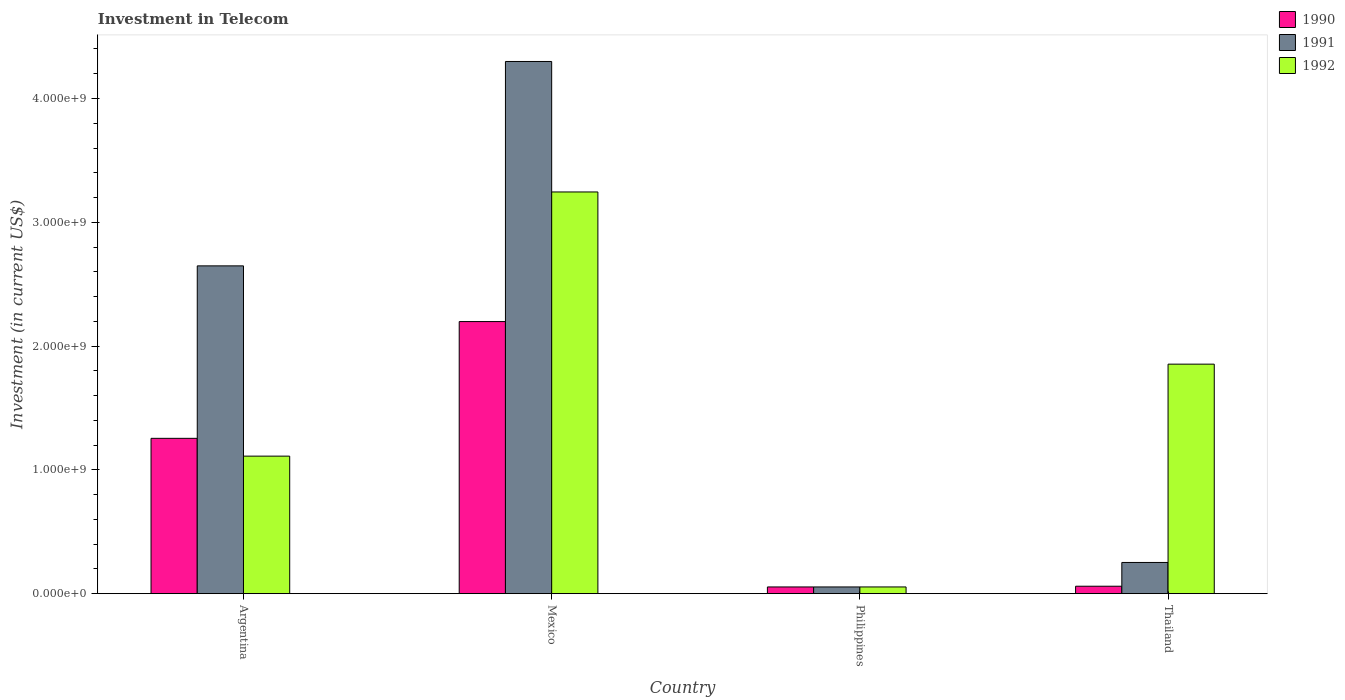How many different coloured bars are there?
Ensure brevity in your answer.  3. Are the number of bars on each tick of the X-axis equal?
Your response must be concise. Yes. How many bars are there on the 4th tick from the left?
Your response must be concise. 3. What is the amount invested in telecom in 1990 in Thailand?
Ensure brevity in your answer.  6.00e+07. Across all countries, what is the maximum amount invested in telecom in 1990?
Offer a terse response. 2.20e+09. Across all countries, what is the minimum amount invested in telecom in 1992?
Ensure brevity in your answer.  5.42e+07. In which country was the amount invested in telecom in 1990 maximum?
Provide a succinct answer. Mexico. In which country was the amount invested in telecom in 1991 minimum?
Make the answer very short. Philippines. What is the total amount invested in telecom in 1992 in the graph?
Your answer should be very brief. 6.26e+09. What is the difference between the amount invested in telecom in 1991 in Mexico and that in Thailand?
Provide a succinct answer. 4.05e+09. What is the difference between the amount invested in telecom in 1990 in Argentina and the amount invested in telecom in 1992 in Thailand?
Ensure brevity in your answer.  -5.99e+08. What is the average amount invested in telecom in 1991 per country?
Make the answer very short. 1.81e+09. What is the difference between the amount invested in telecom of/in 1991 and amount invested in telecom of/in 1990 in Argentina?
Your answer should be very brief. 1.39e+09. What is the ratio of the amount invested in telecom in 1992 in Argentina to that in Mexico?
Offer a terse response. 0.34. What is the difference between the highest and the second highest amount invested in telecom in 1992?
Make the answer very short. 1.39e+09. What is the difference between the highest and the lowest amount invested in telecom in 1991?
Provide a succinct answer. 4.24e+09. In how many countries, is the amount invested in telecom in 1990 greater than the average amount invested in telecom in 1990 taken over all countries?
Provide a short and direct response. 2. What does the 3rd bar from the left in Argentina represents?
Your answer should be very brief. 1992. Is it the case that in every country, the sum of the amount invested in telecom in 1992 and amount invested in telecom in 1991 is greater than the amount invested in telecom in 1990?
Keep it short and to the point. Yes. Are all the bars in the graph horizontal?
Your answer should be compact. No. Are the values on the major ticks of Y-axis written in scientific E-notation?
Offer a very short reply. Yes. Where does the legend appear in the graph?
Your response must be concise. Top right. How many legend labels are there?
Keep it short and to the point. 3. What is the title of the graph?
Provide a succinct answer. Investment in Telecom. Does "1965" appear as one of the legend labels in the graph?
Ensure brevity in your answer.  No. What is the label or title of the Y-axis?
Provide a short and direct response. Investment (in current US$). What is the Investment (in current US$) in 1990 in Argentina?
Make the answer very short. 1.25e+09. What is the Investment (in current US$) in 1991 in Argentina?
Your response must be concise. 2.65e+09. What is the Investment (in current US$) in 1992 in Argentina?
Give a very brief answer. 1.11e+09. What is the Investment (in current US$) of 1990 in Mexico?
Give a very brief answer. 2.20e+09. What is the Investment (in current US$) of 1991 in Mexico?
Your response must be concise. 4.30e+09. What is the Investment (in current US$) in 1992 in Mexico?
Offer a terse response. 3.24e+09. What is the Investment (in current US$) of 1990 in Philippines?
Keep it short and to the point. 5.42e+07. What is the Investment (in current US$) of 1991 in Philippines?
Offer a terse response. 5.42e+07. What is the Investment (in current US$) in 1992 in Philippines?
Your response must be concise. 5.42e+07. What is the Investment (in current US$) in 1990 in Thailand?
Keep it short and to the point. 6.00e+07. What is the Investment (in current US$) of 1991 in Thailand?
Offer a terse response. 2.52e+08. What is the Investment (in current US$) of 1992 in Thailand?
Keep it short and to the point. 1.85e+09. Across all countries, what is the maximum Investment (in current US$) in 1990?
Provide a succinct answer. 2.20e+09. Across all countries, what is the maximum Investment (in current US$) of 1991?
Offer a very short reply. 4.30e+09. Across all countries, what is the maximum Investment (in current US$) in 1992?
Provide a succinct answer. 3.24e+09. Across all countries, what is the minimum Investment (in current US$) in 1990?
Give a very brief answer. 5.42e+07. Across all countries, what is the minimum Investment (in current US$) in 1991?
Keep it short and to the point. 5.42e+07. Across all countries, what is the minimum Investment (in current US$) in 1992?
Your answer should be compact. 5.42e+07. What is the total Investment (in current US$) of 1990 in the graph?
Provide a short and direct response. 3.57e+09. What is the total Investment (in current US$) in 1991 in the graph?
Offer a terse response. 7.25e+09. What is the total Investment (in current US$) of 1992 in the graph?
Provide a short and direct response. 6.26e+09. What is the difference between the Investment (in current US$) of 1990 in Argentina and that in Mexico?
Your response must be concise. -9.43e+08. What is the difference between the Investment (in current US$) in 1991 in Argentina and that in Mexico?
Make the answer very short. -1.65e+09. What is the difference between the Investment (in current US$) of 1992 in Argentina and that in Mexico?
Your answer should be very brief. -2.13e+09. What is the difference between the Investment (in current US$) of 1990 in Argentina and that in Philippines?
Keep it short and to the point. 1.20e+09. What is the difference between the Investment (in current US$) in 1991 in Argentina and that in Philippines?
Your answer should be very brief. 2.59e+09. What is the difference between the Investment (in current US$) of 1992 in Argentina and that in Philippines?
Make the answer very short. 1.06e+09. What is the difference between the Investment (in current US$) of 1990 in Argentina and that in Thailand?
Your response must be concise. 1.19e+09. What is the difference between the Investment (in current US$) of 1991 in Argentina and that in Thailand?
Your response must be concise. 2.40e+09. What is the difference between the Investment (in current US$) in 1992 in Argentina and that in Thailand?
Your response must be concise. -7.43e+08. What is the difference between the Investment (in current US$) of 1990 in Mexico and that in Philippines?
Make the answer very short. 2.14e+09. What is the difference between the Investment (in current US$) of 1991 in Mexico and that in Philippines?
Give a very brief answer. 4.24e+09. What is the difference between the Investment (in current US$) in 1992 in Mexico and that in Philippines?
Offer a terse response. 3.19e+09. What is the difference between the Investment (in current US$) in 1990 in Mexico and that in Thailand?
Make the answer very short. 2.14e+09. What is the difference between the Investment (in current US$) in 1991 in Mexico and that in Thailand?
Ensure brevity in your answer.  4.05e+09. What is the difference between the Investment (in current US$) of 1992 in Mexico and that in Thailand?
Your answer should be very brief. 1.39e+09. What is the difference between the Investment (in current US$) of 1990 in Philippines and that in Thailand?
Your answer should be compact. -5.80e+06. What is the difference between the Investment (in current US$) of 1991 in Philippines and that in Thailand?
Your answer should be compact. -1.98e+08. What is the difference between the Investment (in current US$) in 1992 in Philippines and that in Thailand?
Ensure brevity in your answer.  -1.80e+09. What is the difference between the Investment (in current US$) in 1990 in Argentina and the Investment (in current US$) in 1991 in Mexico?
Your response must be concise. -3.04e+09. What is the difference between the Investment (in current US$) of 1990 in Argentina and the Investment (in current US$) of 1992 in Mexico?
Provide a short and direct response. -1.99e+09. What is the difference between the Investment (in current US$) in 1991 in Argentina and the Investment (in current US$) in 1992 in Mexico?
Your answer should be compact. -5.97e+08. What is the difference between the Investment (in current US$) of 1990 in Argentina and the Investment (in current US$) of 1991 in Philippines?
Offer a very short reply. 1.20e+09. What is the difference between the Investment (in current US$) in 1990 in Argentina and the Investment (in current US$) in 1992 in Philippines?
Provide a succinct answer. 1.20e+09. What is the difference between the Investment (in current US$) of 1991 in Argentina and the Investment (in current US$) of 1992 in Philippines?
Provide a short and direct response. 2.59e+09. What is the difference between the Investment (in current US$) in 1990 in Argentina and the Investment (in current US$) in 1991 in Thailand?
Ensure brevity in your answer.  1.00e+09. What is the difference between the Investment (in current US$) of 1990 in Argentina and the Investment (in current US$) of 1992 in Thailand?
Offer a terse response. -5.99e+08. What is the difference between the Investment (in current US$) of 1991 in Argentina and the Investment (in current US$) of 1992 in Thailand?
Offer a very short reply. 7.94e+08. What is the difference between the Investment (in current US$) in 1990 in Mexico and the Investment (in current US$) in 1991 in Philippines?
Ensure brevity in your answer.  2.14e+09. What is the difference between the Investment (in current US$) of 1990 in Mexico and the Investment (in current US$) of 1992 in Philippines?
Make the answer very short. 2.14e+09. What is the difference between the Investment (in current US$) in 1991 in Mexico and the Investment (in current US$) in 1992 in Philippines?
Make the answer very short. 4.24e+09. What is the difference between the Investment (in current US$) of 1990 in Mexico and the Investment (in current US$) of 1991 in Thailand?
Ensure brevity in your answer.  1.95e+09. What is the difference between the Investment (in current US$) in 1990 in Mexico and the Investment (in current US$) in 1992 in Thailand?
Offer a very short reply. 3.44e+08. What is the difference between the Investment (in current US$) of 1991 in Mexico and the Investment (in current US$) of 1992 in Thailand?
Provide a short and direct response. 2.44e+09. What is the difference between the Investment (in current US$) in 1990 in Philippines and the Investment (in current US$) in 1991 in Thailand?
Ensure brevity in your answer.  -1.98e+08. What is the difference between the Investment (in current US$) in 1990 in Philippines and the Investment (in current US$) in 1992 in Thailand?
Ensure brevity in your answer.  -1.80e+09. What is the difference between the Investment (in current US$) in 1991 in Philippines and the Investment (in current US$) in 1992 in Thailand?
Make the answer very short. -1.80e+09. What is the average Investment (in current US$) in 1990 per country?
Provide a succinct answer. 8.92e+08. What is the average Investment (in current US$) in 1991 per country?
Provide a short and direct response. 1.81e+09. What is the average Investment (in current US$) in 1992 per country?
Provide a short and direct response. 1.57e+09. What is the difference between the Investment (in current US$) in 1990 and Investment (in current US$) in 1991 in Argentina?
Give a very brief answer. -1.39e+09. What is the difference between the Investment (in current US$) of 1990 and Investment (in current US$) of 1992 in Argentina?
Give a very brief answer. 1.44e+08. What is the difference between the Investment (in current US$) in 1991 and Investment (in current US$) in 1992 in Argentina?
Your answer should be very brief. 1.54e+09. What is the difference between the Investment (in current US$) of 1990 and Investment (in current US$) of 1991 in Mexico?
Make the answer very short. -2.10e+09. What is the difference between the Investment (in current US$) of 1990 and Investment (in current US$) of 1992 in Mexico?
Your response must be concise. -1.05e+09. What is the difference between the Investment (in current US$) of 1991 and Investment (in current US$) of 1992 in Mexico?
Your answer should be compact. 1.05e+09. What is the difference between the Investment (in current US$) in 1990 and Investment (in current US$) in 1991 in Philippines?
Provide a short and direct response. 0. What is the difference between the Investment (in current US$) of 1990 and Investment (in current US$) of 1992 in Philippines?
Provide a succinct answer. 0. What is the difference between the Investment (in current US$) of 1991 and Investment (in current US$) of 1992 in Philippines?
Provide a short and direct response. 0. What is the difference between the Investment (in current US$) in 1990 and Investment (in current US$) in 1991 in Thailand?
Your answer should be compact. -1.92e+08. What is the difference between the Investment (in current US$) of 1990 and Investment (in current US$) of 1992 in Thailand?
Keep it short and to the point. -1.79e+09. What is the difference between the Investment (in current US$) in 1991 and Investment (in current US$) in 1992 in Thailand?
Offer a very short reply. -1.60e+09. What is the ratio of the Investment (in current US$) of 1990 in Argentina to that in Mexico?
Your answer should be compact. 0.57. What is the ratio of the Investment (in current US$) in 1991 in Argentina to that in Mexico?
Your answer should be compact. 0.62. What is the ratio of the Investment (in current US$) of 1992 in Argentina to that in Mexico?
Provide a short and direct response. 0.34. What is the ratio of the Investment (in current US$) of 1990 in Argentina to that in Philippines?
Make the answer very short. 23.15. What is the ratio of the Investment (in current US$) of 1991 in Argentina to that in Philippines?
Provide a short and direct response. 48.86. What is the ratio of the Investment (in current US$) of 1992 in Argentina to that in Philippines?
Provide a succinct answer. 20.5. What is the ratio of the Investment (in current US$) in 1990 in Argentina to that in Thailand?
Keep it short and to the point. 20.91. What is the ratio of the Investment (in current US$) of 1991 in Argentina to that in Thailand?
Give a very brief answer. 10.51. What is the ratio of the Investment (in current US$) of 1992 in Argentina to that in Thailand?
Your answer should be very brief. 0.6. What is the ratio of the Investment (in current US$) of 1990 in Mexico to that in Philippines?
Ensure brevity in your answer.  40.55. What is the ratio of the Investment (in current US$) of 1991 in Mexico to that in Philippines?
Keep it short and to the point. 79.32. What is the ratio of the Investment (in current US$) in 1992 in Mexico to that in Philippines?
Offer a terse response. 59.87. What is the ratio of the Investment (in current US$) in 1990 in Mexico to that in Thailand?
Ensure brevity in your answer.  36.63. What is the ratio of the Investment (in current US$) of 1991 in Mexico to that in Thailand?
Give a very brief answer. 17.06. What is the ratio of the Investment (in current US$) of 1992 in Mexico to that in Thailand?
Ensure brevity in your answer.  1.75. What is the ratio of the Investment (in current US$) in 1990 in Philippines to that in Thailand?
Your answer should be compact. 0.9. What is the ratio of the Investment (in current US$) of 1991 in Philippines to that in Thailand?
Your answer should be compact. 0.22. What is the ratio of the Investment (in current US$) in 1992 in Philippines to that in Thailand?
Your answer should be very brief. 0.03. What is the difference between the highest and the second highest Investment (in current US$) of 1990?
Offer a terse response. 9.43e+08. What is the difference between the highest and the second highest Investment (in current US$) of 1991?
Make the answer very short. 1.65e+09. What is the difference between the highest and the second highest Investment (in current US$) of 1992?
Make the answer very short. 1.39e+09. What is the difference between the highest and the lowest Investment (in current US$) in 1990?
Your response must be concise. 2.14e+09. What is the difference between the highest and the lowest Investment (in current US$) of 1991?
Ensure brevity in your answer.  4.24e+09. What is the difference between the highest and the lowest Investment (in current US$) in 1992?
Your answer should be compact. 3.19e+09. 